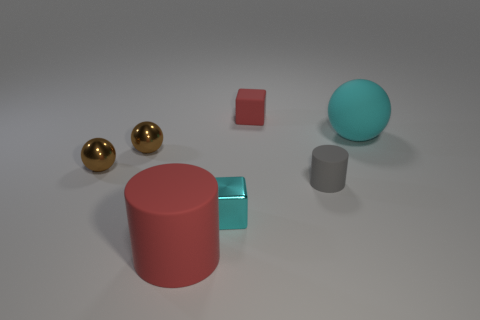There is a thing that is the same color as the large cylinder; what is its size?
Your response must be concise. Small. Are there any metallic balls on the left side of the rubber cylinder that is behind the cyan metal object?
Make the answer very short. Yes. Are there the same number of large rubber balls on the left side of the tiny gray cylinder and large cyan balls?
Make the answer very short. No. How many small cyan metallic blocks are on the right side of the cube that is to the left of the small cube behind the big rubber ball?
Make the answer very short. 0. Is there a ball that has the same size as the gray rubber object?
Keep it short and to the point. Yes. Is the number of large spheres that are in front of the cyan rubber thing less than the number of rubber cubes?
Provide a succinct answer. Yes. The cyan thing that is in front of the big thing that is behind the matte cylinder that is on the right side of the red matte block is made of what material?
Make the answer very short. Metal. Are there more tiny cyan shiny cubes in front of the gray cylinder than small cylinders that are in front of the tiny metal block?
Offer a terse response. Yes. What number of shiny objects are either red things or brown spheres?
Make the answer very short. 2. The rubber thing that is the same color as the matte cube is what shape?
Offer a terse response. Cylinder. 